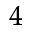Convert formula to latex. <formula><loc_0><loc_0><loc_500><loc_500>_ { 4 }</formula> 